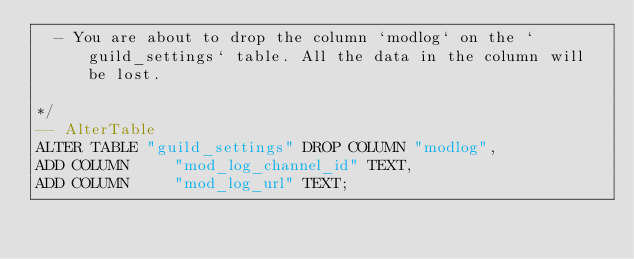<code> <loc_0><loc_0><loc_500><loc_500><_SQL_>  - You are about to drop the column `modlog` on the `guild_settings` table. All the data in the column will be lost.

*/
-- AlterTable
ALTER TABLE "guild_settings" DROP COLUMN "modlog",
ADD COLUMN     "mod_log_channel_id" TEXT,
ADD COLUMN     "mod_log_url" TEXT;
</code> 